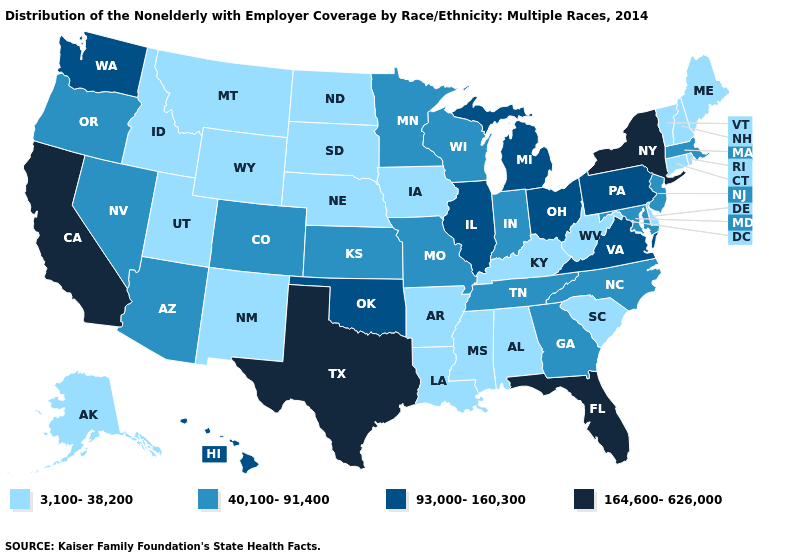Which states have the lowest value in the South?
Short answer required. Alabama, Arkansas, Delaware, Kentucky, Louisiana, Mississippi, South Carolina, West Virginia. What is the highest value in the South ?
Answer briefly. 164,600-626,000. What is the highest value in states that border North Carolina?
Write a very short answer. 93,000-160,300. What is the value of California?
Keep it brief. 164,600-626,000. What is the highest value in the Northeast ?
Answer briefly. 164,600-626,000. Does Alabama have the same value as Indiana?
Give a very brief answer. No. Among the states that border Texas , which have the lowest value?
Quick response, please. Arkansas, Louisiana, New Mexico. Name the states that have a value in the range 93,000-160,300?
Write a very short answer. Hawaii, Illinois, Michigan, Ohio, Oklahoma, Pennsylvania, Virginia, Washington. Name the states that have a value in the range 40,100-91,400?
Give a very brief answer. Arizona, Colorado, Georgia, Indiana, Kansas, Maryland, Massachusetts, Minnesota, Missouri, Nevada, New Jersey, North Carolina, Oregon, Tennessee, Wisconsin. What is the value of Tennessee?
Keep it brief. 40,100-91,400. Does California have the highest value in the West?
Answer briefly. Yes. What is the highest value in the South ?
Short answer required. 164,600-626,000. Which states have the lowest value in the South?
Write a very short answer. Alabama, Arkansas, Delaware, Kentucky, Louisiana, Mississippi, South Carolina, West Virginia. Among the states that border Nebraska , does Colorado have the highest value?
Be succinct. Yes. 